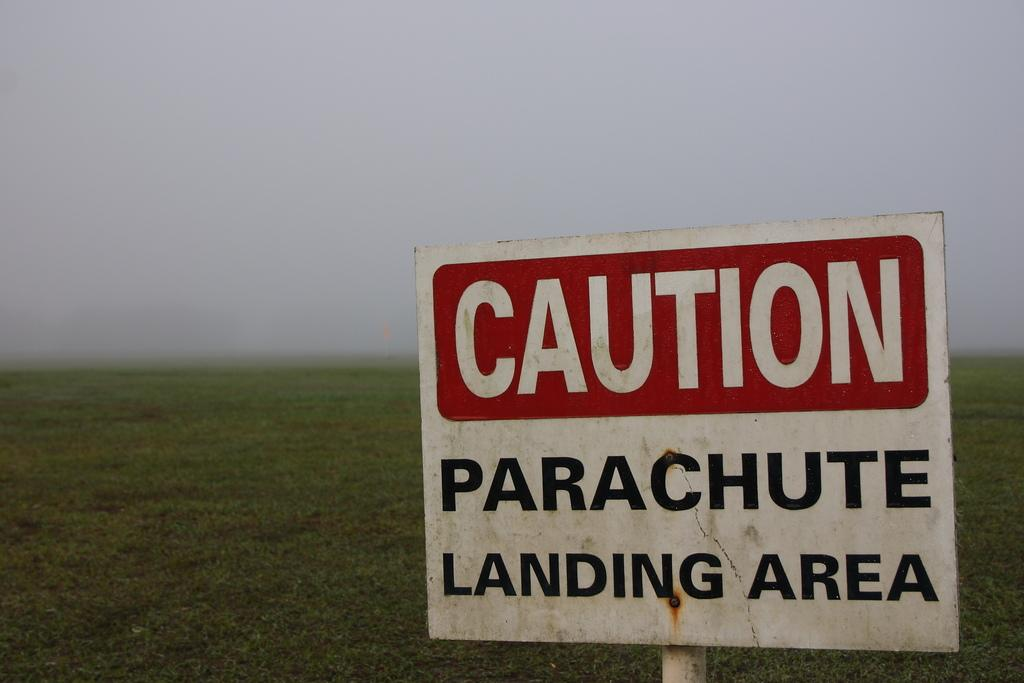<image>
Give a short and clear explanation of the subsequent image. A sign cautions about a parachute landing area. 